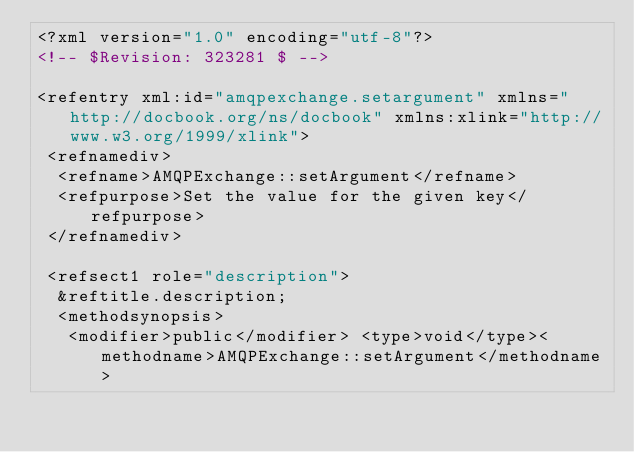Convert code to text. <code><loc_0><loc_0><loc_500><loc_500><_XML_><?xml version="1.0" encoding="utf-8"?>
<!-- $Revision: 323281 $ -->

<refentry xml:id="amqpexchange.setargument" xmlns="http://docbook.org/ns/docbook" xmlns:xlink="http://www.w3.org/1999/xlink">
 <refnamediv>
  <refname>AMQPExchange::setArgument</refname>
  <refpurpose>Set the value for the given key</refpurpose>
 </refnamediv>

 <refsect1 role="description">
  &reftitle.description;
  <methodsynopsis>
   <modifier>public</modifier> <type>void</type><methodname>AMQPExchange::setArgument</methodname></code> 